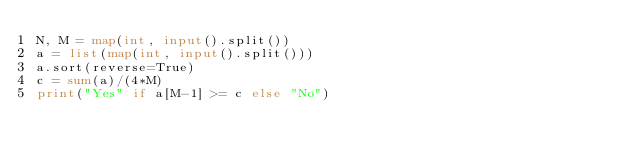<code> <loc_0><loc_0><loc_500><loc_500><_Python_>N, M = map(int, input().split())
a = list(map(int, input().split()))
a.sort(reverse=True)
c = sum(a)/(4*M)
print("Yes" if a[M-1] >= c else "No")
</code> 